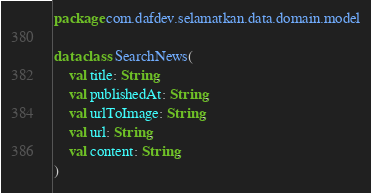<code> <loc_0><loc_0><loc_500><loc_500><_Kotlin_>package com.dafdev.selamatkan.data.domain.model

data class SearchNews(
    val title: String,
    val publishedAt: String,
    val urlToImage: String,
    val url: String,
    val content: String,
)
</code> 